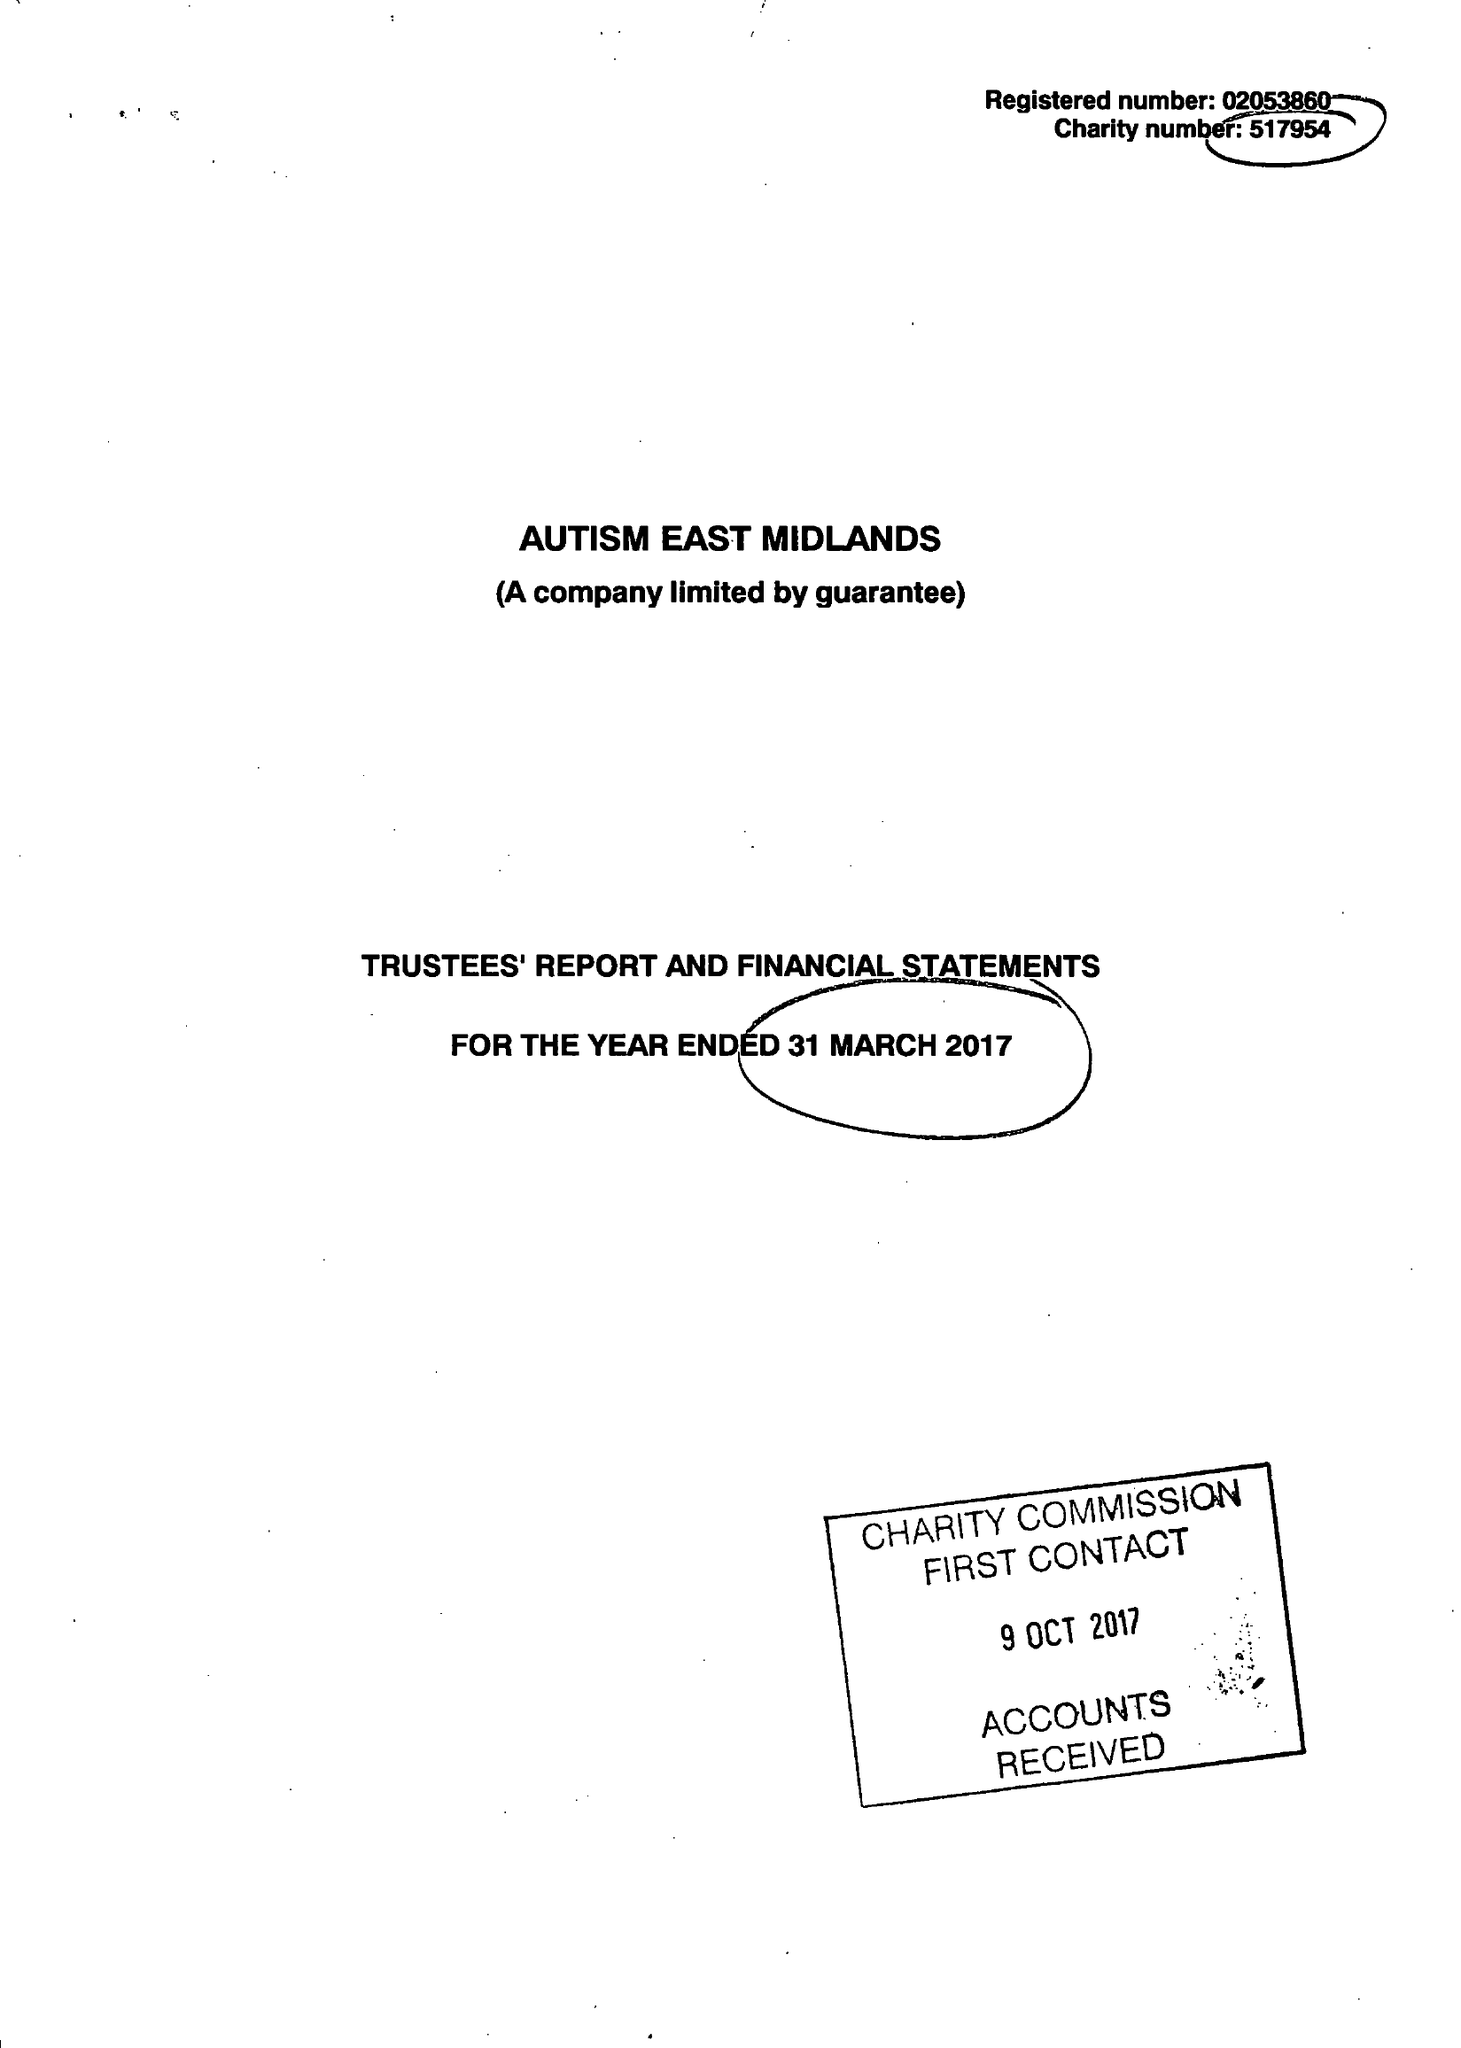What is the value for the income_annually_in_british_pounds?
Answer the question using a single word or phrase. 11426153.00 